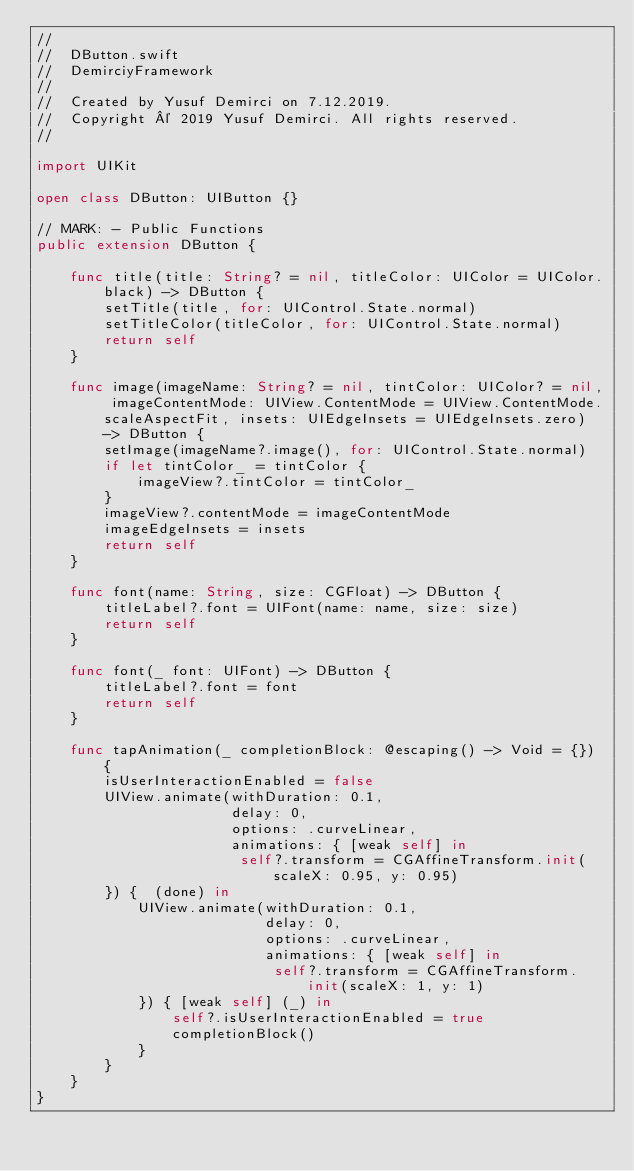Convert code to text. <code><loc_0><loc_0><loc_500><loc_500><_Swift_>//
//  DButton.swift
//  DemirciyFramework
//
//  Created by Yusuf Demirci on 7.12.2019.
//  Copyright © 2019 Yusuf Demirci. All rights reserved.
//

import UIKit

open class DButton: UIButton {}

// MARK: - Public Functions
public extension DButton {
    
    func title(title: String? = nil, titleColor: UIColor = UIColor.black) -> DButton {
        setTitle(title, for: UIControl.State.normal)
        setTitleColor(titleColor, for: UIControl.State.normal)
        return self
    }
    
    func image(imageName: String? = nil, tintColor: UIColor? = nil, imageContentMode: UIView.ContentMode = UIView.ContentMode.scaleAspectFit, insets: UIEdgeInsets = UIEdgeInsets.zero) -> DButton {
        setImage(imageName?.image(), for: UIControl.State.normal)
        if let tintColor_ = tintColor {
            imageView?.tintColor = tintColor_
        }
        imageView?.contentMode = imageContentMode
        imageEdgeInsets = insets
        return self
    }
    
    func font(name: String, size: CGFloat) -> DButton {
        titleLabel?.font = UIFont(name: name, size: size)
        return self
    }
    
    func font(_ font: UIFont) -> DButton {
        titleLabel?.font = font
        return self
    }
    
    func tapAnimation(_ completionBlock: @escaping() -> Void = {}) {
        isUserInteractionEnabled = false
        UIView.animate(withDuration: 0.1,
                       delay: 0,
                       options: .curveLinear,
                       animations: { [weak self] in
                        self?.transform = CGAffineTransform.init(scaleX: 0.95, y: 0.95)
        }) {  (done) in
            UIView.animate(withDuration: 0.1,
                           delay: 0,
                           options: .curveLinear,
                           animations: { [weak self] in
                            self?.transform = CGAffineTransform.init(scaleX: 1, y: 1)
            }) { [weak self] (_) in
                self?.isUserInteractionEnabled = true
                completionBlock()
            }
        }
    }
}
</code> 